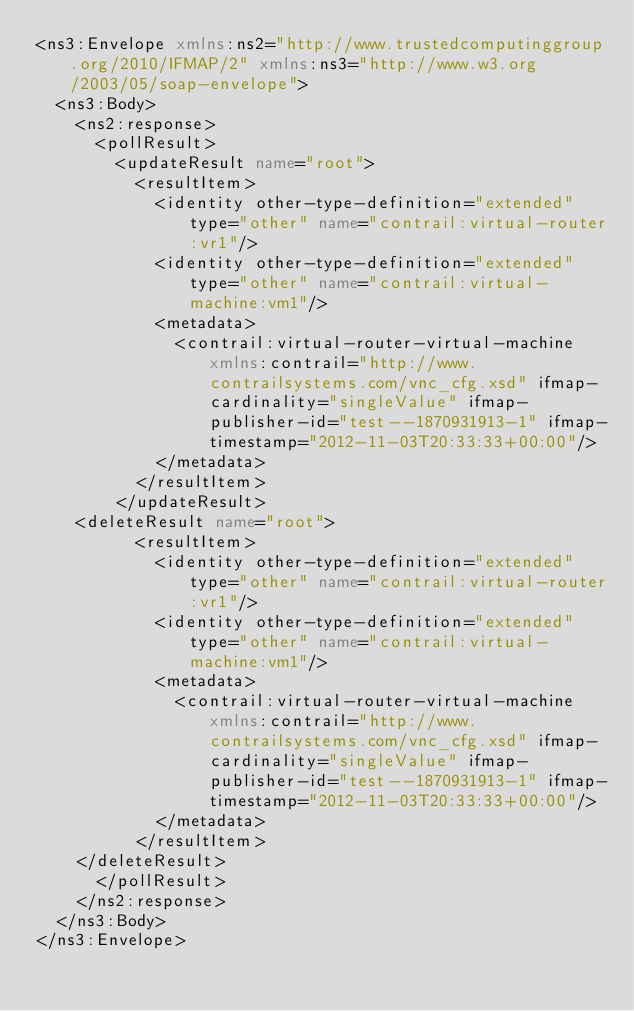<code> <loc_0><loc_0><loc_500><loc_500><_XML_><ns3:Envelope xmlns:ns2="http://www.trustedcomputinggroup.org/2010/IFMAP/2" xmlns:ns3="http://www.w3.org/2003/05/soap-envelope">
  <ns3:Body>
    <ns2:response>
      <pollResult>
        <updateResult name="root">
          <resultItem>
            <identity other-type-definition="extended" type="other" name="contrail:virtual-router:vr1"/>
            <identity other-type-definition="extended" type="other" name="contrail:virtual-machine:vm1"/>
            <metadata>
              <contrail:virtual-router-virtual-machine xmlns:contrail="http://www.contrailsystems.com/vnc_cfg.xsd" ifmap-cardinality="singleValue" ifmap-publisher-id="test--1870931913-1" ifmap-timestamp="2012-11-03T20:33:33+00:00"/>
            </metadata>
          </resultItem>
        </updateResult>
	<deleteResult name="root">
          <resultItem>
            <identity other-type-definition="extended" type="other" name="contrail:virtual-router:vr1"/>
            <identity other-type-definition="extended" type="other" name="contrail:virtual-machine:vm1"/>
            <metadata>
              <contrail:virtual-router-virtual-machine xmlns:contrail="http://www.contrailsystems.com/vnc_cfg.xsd" ifmap-cardinality="singleValue" ifmap-publisher-id="test--1870931913-1" ifmap-timestamp="2012-11-03T20:33:33+00:00"/>
            </metadata>
          </resultItem>
	</deleteResult>
      </pollResult>
    </ns2:response>
  </ns3:Body>
</ns3:Envelope>
</code> 